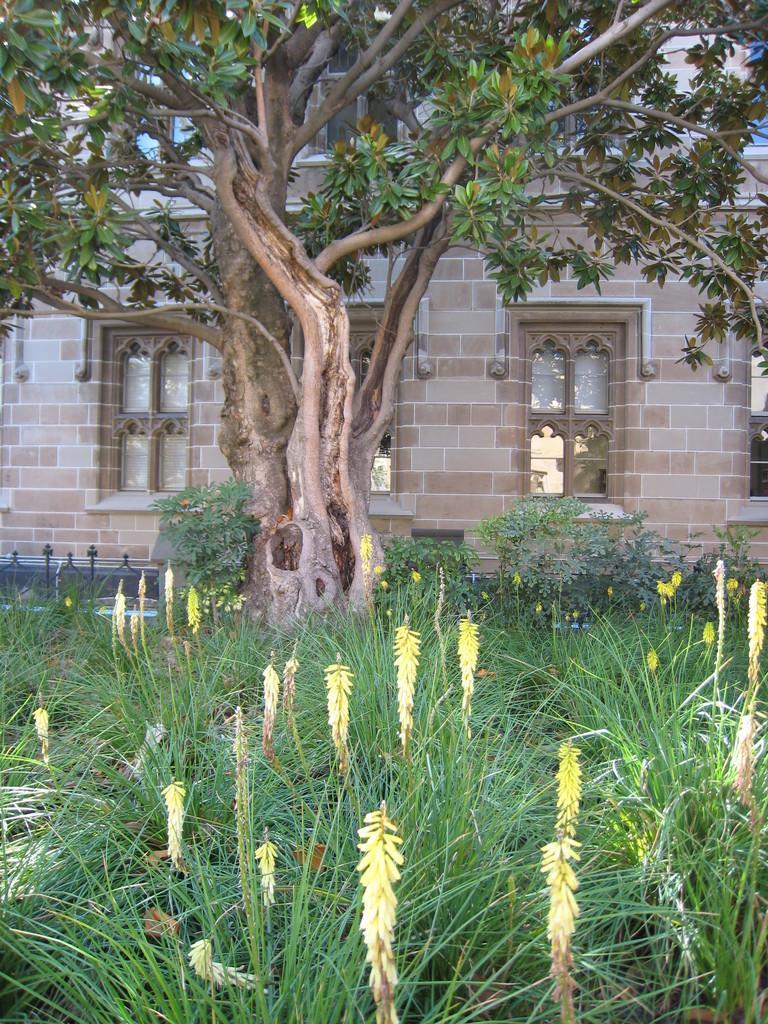How would you summarize this image in a sentence or two? In this picture we can see planets at the bottom, there is a tree in the middle, in the background we can see a house. 